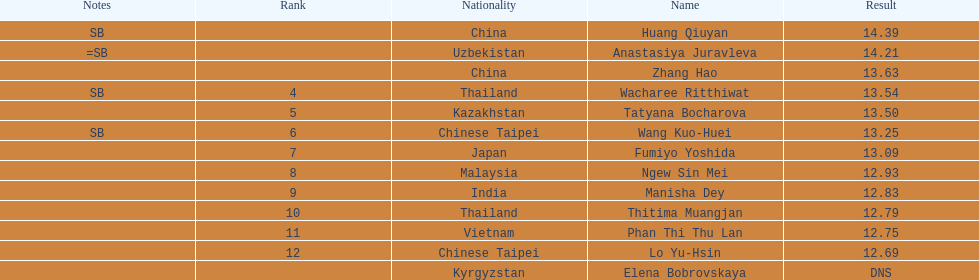Which country came in first? China. 